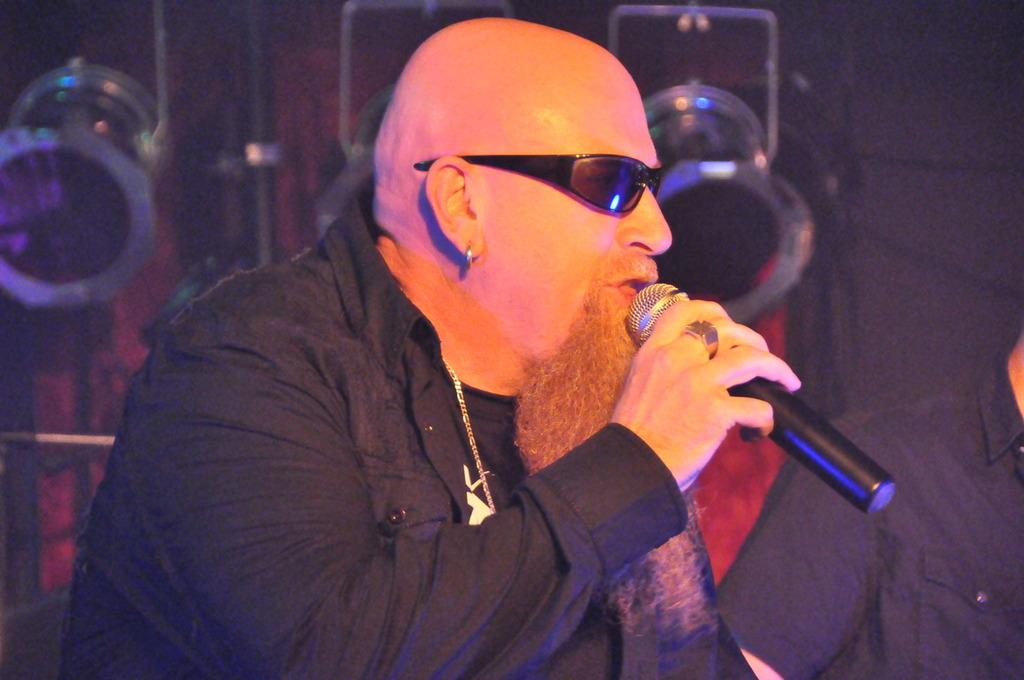What is the main subject of the image? The main subject of the image is a man. What is the man wearing in the image? The man is wearing a jacket and goggles in the image. What is the man holding in his hand? The man is holding a microphone in his hand. Can you describe the background of the image? There is another person and light visible in the background of the image. What type of trees can be seen in the background of the image? There are no trees visible in the background of the image. What kind of club is the man holding in his hand? The man is not holding a club in his hand; he is holding a microphone. 